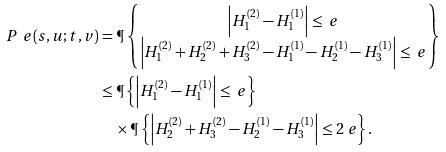<formula> <loc_0><loc_0><loc_500><loc_500>P _ { \ } e ( s , u ; t , v ) & = \P \left \{ \begin{matrix} \left | H ^ { ( 2 ) } _ { 1 } - H ^ { ( 1 ) } _ { 1 } \right | \leq \ e \\ \left | H ^ { ( 2 ) } _ { 1 } + H ^ { ( 2 ) } _ { 2 } + H ^ { ( 2 ) } _ { 3 } - H ^ { ( 1 ) } _ { 1 } - H ^ { ( 1 ) } _ { 2 } - H ^ { ( 1 ) } _ { 3 } \right | \leq \ e \end{matrix} \right \} \\ & \leq \P \left \{ \left | H ^ { ( 2 ) } _ { 1 } - H ^ { ( 1 ) } _ { 1 } \right | \leq \ e \right \} \\ & \quad \times \P \left \{ \left | H ^ { ( 2 ) } _ { 2 } + H ^ { ( 2 ) } _ { 3 } - H ^ { ( 1 ) } _ { 2 } - H ^ { ( 1 ) } _ { 3 } \right | \leq 2 \ e \right \} .</formula> 